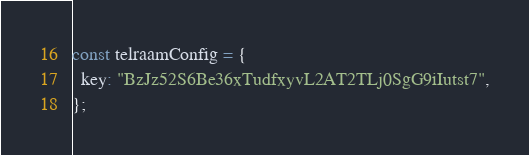Convert code to text. <code><loc_0><loc_0><loc_500><loc_500><_JavaScript_>const telraamConfig = {
  key: "BzJz52S6Be36xTudfxyvL2AT2TLj0SgG9iIutst7",
};
</code> 